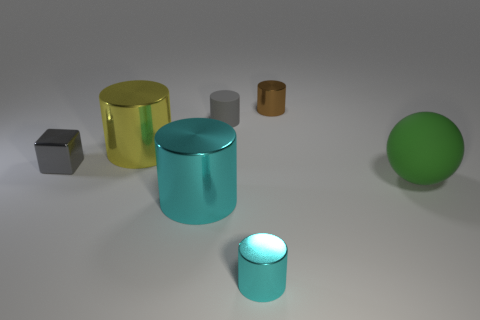How many cyan cylinders have the same size as the gray shiny thing? Upon reviewing the image, it appears that there is one cyan cylinder of similar dimensions to the gray metallic object. 